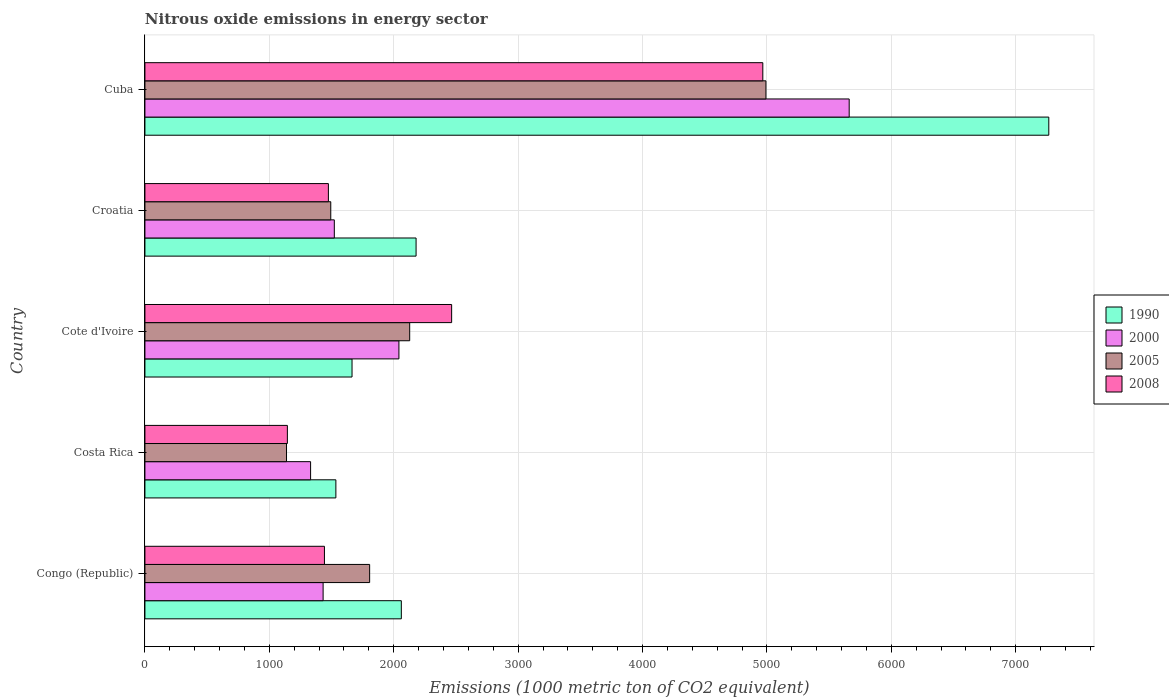How many groups of bars are there?
Your answer should be very brief. 5. Are the number of bars per tick equal to the number of legend labels?
Your answer should be very brief. Yes. Are the number of bars on each tick of the Y-axis equal?
Ensure brevity in your answer.  Yes. How many bars are there on the 2nd tick from the bottom?
Offer a very short reply. 4. What is the label of the 3rd group of bars from the top?
Your answer should be very brief. Cote d'Ivoire. In how many cases, is the number of bars for a given country not equal to the number of legend labels?
Offer a terse response. 0. What is the amount of nitrous oxide emitted in 2008 in Cuba?
Keep it short and to the point. 4967. Across all countries, what is the maximum amount of nitrous oxide emitted in 2005?
Keep it short and to the point. 4992.1. Across all countries, what is the minimum amount of nitrous oxide emitted in 2008?
Offer a terse response. 1145.2. In which country was the amount of nitrous oxide emitted in 2005 maximum?
Make the answer very short. Cuba. What is the total amount of nitrous oxide emitted in 1990 in the graph?
Offer a terse response. 1.47e+04. What is the difference between the amount of nitrous oxide emitted in 2000 in Cote d'Ivoire and that in Croatia?
Make the answer very short. 519.3. What is the difference between the amount of nitrous oxide emitted in 2000 in Croatia and the amount of nitrous oxide emitted in 2005 in Costa Rica?
Offer a terse response. 384.3. What is the average amount of nitrous oxide emitted in 2000 per country?
Provide a succinct answer. 2397.96. In how many countries, is the amount of nitrous oxide emitted in 1990 greater than 3800 1000 metric ton?
Your answer should be compact. 1. What is the ratio of the amount of nitrous oxide emitted in 2008 in Cote d'Ivoire to that in Cuba?
Give a very brief answer. 0.5. What is the difference between the highest and the second highest amount of nitrous oxide emitted in 2005?
Give a very brief answer. 2863.8. What is the difference between the highest and the lowest amount of nitrous oxide emitted in 2008?
Your answer should be very brief. 3821.8. In how many countries, is the amount of nitrous oxide emitted in 2000 greater than the average amount of nitrous oxide emitted in 2000 taken over all countries?
Your answer should be compact. 1. Is the sum of the amount of nitrous oxide emitted in 2005 in Congo (Republic) and Cuba greater than the maximum amount of nitrous oxide emitted in 2000 across all countries?
Your answer should be very brief. Yes. What does the 1st bar from the top in Costa Rica represents?
Provide a short and direct response. 2008. What is the difference between two consecutive major ticks on the X-axis?
Offer a terse response. 1000. Does the graph contain grids?
Your response must be concise. Yes. How many legend labels are there?
Your answer should be very brief. 4. How are the legend labels stacked?
Ensure brevity in your answer.  Vertical. What is the title of the graph?
Keep it short and to the point. Nitrous oxide emissions in energy sector. What is the label or title of the X-axis?
Provide a succinct answer. Emissions (1000 metric ton of CO2 equivalent). What is the label or title of the Y-axis?
Provide a short and direct response. Country. What is the Emissions (1000 metric ton of CO2 equivalent) in 1990 in Congo (Republic)?
Ensure brevity in your answer.  2061.2. What is the Emissions (1000 metric ton of CO2 equivalent) in 2000 in Congo (Republic)?
Make the answer very short. 1432.4. What is the Emissions (1000 metric ton of CO2 equivalent) of 2005 in Congo (Republic)?
Provide a short and direct response. 1806.4. What is the Emissions (1000 metric ton of CO2 equivalent) of 2008 in Congo (Republic)?
Provide a short and direct response. 1443.1. What is the Emissions (1000 metric ton of CO2 equivalent) of 1990 in Costa Rica?
Provide a succinct answer. 1535. What is the Emissions (1000 metric ton of CO2 equivalent) in 2000 in Costa Rica?
Offer a terse response. 1331.8. What is the Emissions (1000 metric ton of CO2 equivalent) in 2005 in Costa Rica?
Provide a succinct answer. 1138.2. What is the Emissions (1000 metric ton of CO2 equivalent) of 2008 in Costa Rica?
Your response must be concise. 1145.2. What is the Emissions (1000 metric ton of CO2 equivalent) of 1990 in Cote d'Ivoire?
Make the answer very short. 1664.9. What is the Emissions (1000 metric ton of CO2 equivalent) in 2000 in Cote d'Ivoire?
Keep it short and to the point. 2041.8. What is the Emissions (1000 metric ton of CO2 equivalent) in 2005 in Cote d'Ivoire?
Your answer should be compact. 2128.3. What is the Emissions (1000 metric ton of CO2 equivalent) in 2008 in Cote d'Ivoire?
Keep it short and to the point. 2465.6. What is the Emissions (1000 metric ton of CO2 equivalent) of 1990 in Croatia?
Provide a short and direct response. 2179.7. What is the Emissions (1000 metric ton of CO2 equivalent) of 2000 in Croatia?
Offer a terse response. 1522.5. What is the Emissions (1000 metric ton of CO2 equivalent) in 2005 in Croatia?
Offer a very short reply. 1494. What is the Emissions (1000 metric ton of CO2 equivalent) of 2008 in Croatia?
Keep it short and to the point. 1474.8. What is the Emissions (1000 metric ton of CO2 equivalent) in 1990 in Cuba?
Ensure brevity in your answer.  7265.9. What is the Emissions (1000 metric ton of CO2 equivalent) of 2000 in Cuba?
Your response must be concise. 5661.3. What is the Emissions (1000 metric ton of CO2 equivalent) of 2005 in Cuba?
Provide a short and direct response. 4992.1. What is the Emissions (1000 metric ton of CO2 equivalent) of 2008 in Cuba?
Give a very brief answer. 4967. Across all countries, what is the maximum Emissions (1000 metric ton of CO2 equivalent) of 1990?
Offer a terse response. 7265.9. Across all countries, what is the maximum Emissions (1000 metric ton of CO2 equivalent) of 2000?
Your answer should be compact. 5661.3. Across all countries, what is the maximum Emissions (1000 metric ton of CO2 equivalent) in 2005?
Provide a short and direct response. 4992.1. Across all countries, what is the maximum Emissions (1000 metric ton of CO2 equivalent) of 2008?
Your answer should be very brief. 4967. Across all countries, what is the minimum Emissions (1000 metric ton of CO2 equivalent) in 1990?
Your answer should be compact. 1535. Across all countries, what is the minimum Emissions (1000 metric ton of CO2 equivalent) of 2000?
Make the answer very short. 1331.8. Across all countries, what is the minimum Emissions (1000 metric ton of CO2 equivalent) in 2005?
Make the answer very short. 1138.2. Across all countries, what is the minimum Emissions (1000 metric ton of CO2 equivalent) of 2008?
Offer a terse response. 1145.2. What is the total Emissions (1000 metric ton of CO2 equivalent) in 1990 in the graph?
Keep it short and to the point. 1.47e+04. What is the total Emissions (1000 metric ton of CO2 equivalent) of 2000 in the graph?
Offer a terse response. 1.20e+04. What is the total Emissions (1000 metric ton of CO2 equivalent) in 2005 in the graph?
Offer a terse response. 1.16e+04. What is the total Emissions (1000 metric ton of CO2 equivalent) in 2008 in the graph?
Offer a very short reply. 1.15e+04. What is the difference between the Emissions (1000 metric ton of CO2 equivalent) in 1990 in Congo (Republic) and that in Costa Rica?
Provide a succinct answer. 526.2. What is the difference between the Emissions (1000 metric ton of CO2 equivalent) in 2000 in Congo (Republic) and that in Costa Rica?
Give a very brief answer. 100.6. What is the difference between the Emissions (1000 metric ton of CO2 equivalent) of 2005 in Congo (Republic) and that in Costa Rica?
Ensure brevity in your answer.  668.2. What is the difference between the Emissions (1000 metric ton of CO2 equivalent) in 2008 in Congo (Republic) and that in Costa Rica?
Offer a very short reply. 297.9. What is the difference between the Emissions (1000 metric ton of CO2 equivalent) of 1990 in Congo (Republic) and that in Cote d'Ivoire?
Ensure brevity in your answer.  396.3. What is the difference between the Emissions (1000 metric ton of CO2 equivalent) in 2000 in Congo (Republic) and that in Cote d'Ivoire?
Offer a terse response. -609.4. What is the difference between the Emissions (1000 metric ton of CO2 equivalent) of 2005 in Congo (Republic) and that in Cote d'Ivoire?
Keep it short and to the point. -321.9. What is the difference between the Emissions (1000 metric ton of CO2 equivalent) of 2008 in Congo (Republic) and that in Cote d'Ivoire?
Offer a terse response. -1022.5. What is the difference between the Emissions (1000 metric ton of CO2 equivalent) in 1990 in Congo (Republic) and that in Croatia?
Your response must be concise. -118.5. What is the difference between the Emissions (1000 metric ton of CO2 equivalent) in 2000 in Congo (Republic) and that in Croatia?
Your answer should be very brief. -90.1. What is the difference between the Emissions (1000 metric ton of CO2 equivalent) of 2005 in Congo (Republic) and that in Croatia?
Provide a succinct answer. 312.4. What is the difference between the Emissions (1000 metric ton of CO2 equivalent) in 2008 in Congo (Republic) and that in Croatia?
Ensure brevity in your answer.  -31.7. What is the difference between the Emissions (1000 metric ton of CO2 equivalent) in 1990 in Congo (Republic) and that in Cuba?
Your response must be concise. -5204.7. What is the difference between the Emissions (1000 metric ton of CO2 equivalent) of 2000 in Congo (Republic) and that in Cuba?
Offer a very short reply. -4228.9. What is the difference between the Emissions (1000 metric ton of CO2 equivalent) in 2005 in Congo (Republic) and that in Cuba?
Provide a succinct answer. -3185.7. What is the difference between the Emissions (1000 metric ton of CO2 equivalent) of 2008 in Congo (Republic) and that in Cuba?
Your answer should be compact. -3523.9. What is the difference between the Emissions (1000 metric ton of CO2 equivalent) of 1990 in Costa Rica and that in Cote d'Ivoire?
Provide a succinct answer. -129.9. What is the difference between the Emissions (1000 metric ton of CO2 equivalent) in 2000 in Costa Rica and that in Cote d'Ivoire?
Give a very brief answer. -710. What is the difference between the Emissions (1000 metric ton of CO2 equivalent) in 2005 in Costa Rica and that in Cote d'Ivoire?
Your answer should be compact. -990.1. What is the difference between the Emissions (1000 metric ton of CO2 equivalent) in 2008 in Costa Rica and that in Cote d'Ivoire?
Ensure brevity in your answer.  -1320.4. What is the difference between the Emissions (1000 metric ton of CO2 equivalent) in 1990 in Costa Rica and that in Croatia?
Provide a succinct answer. -644.7. What is the difference between the Emissions (1000 metric ton of CO2 equivalent) of 2000 in Costa Rica and that in Croatia?
Keep it short and to the point. -190.7. What is the difference between the Emissions (1000 metric ton of CO2 equivalent) of 2005 in Costa Rica and that in Croatia?
Give a very brief answer. -355.8. What is the difference between the Emissions (1000 metric ton of CO2 equivalent) of 2008 in Costa Rica and that in Croatia?
Ensure brevity in your answer.  -329.6. What is the difference between the Emissions (1000 metric ton of CO2 equivalent) of 1990 in Costa Rica and that in Cuba?
Your answer should be compact. -5730.9. What is the difference between the Emissions (1000 metric ton of CO2 equivalent) in 2000 in Costa Rica and that in Cuba?
Offer a terse response. -4329.5. What is the difference between the Emissions (1000 metric ton of CO2 equivalent) in 2005 in Costa Rica and that in Cuba?
Offer a very short reply. -3853.9. What is the difference between the Emissions (1000 metric ton of CO2 equivalent) in 2008 in Costa Rica and that in Cuba?
Keep it short and to the point. -3821.8. What is the difference between the Emissions (1000 metric ton of CO2 equivalent) in 1990 in Cote d'Ivoire and that in Croatia?
Make the answer very short. -514.8. What is the difference between the Emissions (1000 metric ton of CO2 equivalent) of 2000 in Cote d'Ivoire and that in Croatia?
Offer a very short reply. 519.3. What is the difference between the Emissions (1000 metric ton of CO2 equivalent) in 2005 in Cote d'Ivoire and that in Croatia?
Make the answer very short. 634.3. What is the difference between the Emissions (1000 metric ton of CO2 equivalent) of 2008 in Cote d'Ivoire and that in Croatia?
Provide a succinct answer. 990.8. What is the difference between the Emissions (1000 metric ton of CO2 equivalent) in 1990 in Cote d'Ivoire and that in Cuba?
Provide a short and direct response. -5601. What is the difference between the Emissions (1000 metric ton of CO2 equivalent) of 2000 in Cote d'Ivoire and that in Cuba?
Offer a terse response. -3619.5. What is the difference between the Emissions (1000 metric ton of CO2 equivalent) of 2005 in Cote d'Ivoire and that in Cuba?
Ensure brevity in your answer.  -2863.8. What is the difference between the Emissions (1000 metric ton of CO2 equivalent) in 2008 in Cote d'Ivoire and that in Cuba?
Give a very brief answer. -2501.4. What is the difference between the Emissions (1000 metric ton of CO2 equivalent) of 1990 in Croatia and that in Cuba?
Provide a succinct answer. -5086.2. What is the difference between the Emissions (1000 metric ton of CO2 equivalent) in 2000 in Croatia and that in Cuba?
Keep it short and to the point. -4138.8. What is the difference between the Emissions (1000 metric ton of CO2 equivalent) of 2005 in Croatia and that in Cuba?
Your answer should be very brief. -3498.1. What is the difference between the Emissions (1000 metric ton of CO2 equivalent) in 2008 in Croatia and that in Cuba?
Your response must be concise. -3492.2. What is the difference between the Emissions (1000 metric ton of CO2 equivalent) in 1990 in Congo (Republic) and the Emissions (1000 metric ton of CO2 equivalent) in 2000 in Costa Rica?
Offer a terse response. 729.4. What is the difference between the Emissions (1000 metric ton of CO2 equivalent) of 1990 in Congo (Republic) and the Emissions (1000 metric ton of CO2 equivalent) of 2005 in Costa Rica?
Your answer should be very brief. 923. What is the difference between the Emissions (1000 metric ton of CO2 equivalent) of 1990 in Congo (Republic) and the Emissions (1000 metric ton of CO2 equivalent) of 2008 in Costa Rica?
Offer a very short reply. 916. What is the difference between the Emissions (1000 metric ton of CO2 equivalent) in 2000 in Congo (Republic) and the Emissions (1000 metric ton of CO2 equivalent) in 2005 in Costa Rica?
Offer a terse response. 294.2. What is the difference between the Emissions (1000 metric ton of CO2 equivalent) of 2000 in Congo (Republic) and the Emissions (1000 metric ton of CO2 equivalent) of 2008 in Costa Rica?
Provide a short and direct response. 287.2. What is the difference between the Emissions (1000 metric ton of CO2 equivalent) of 2005 in Congo (Republic) and the Emissions (1000 metric ton of CO2 equivalent) of 2008 in Costa Rica?
Make the answer very short. 661.2. What is the difference between the Emissions (1000 metric ton of CO2 equivalent) in 1990 in Congo (Republic) and the Emissions (1000 metric ton of CO2 equivalent) in 2005 in Cote d'Ivoire?
Make the answer very short. -67.1. What is the difference between the Emissions (1000 metric ton of CO2 equivalent) in 1990 in Congo (Republic) and the Emissions (1000 metric ton of CO2 equivalent) in 2008 in Cote d'Ivoire?
Make the answer very short. -404.4. What is the difference between the Emissions (1000 metric ton of CO2 equivalent) of 2000 in Congo (Republic) and the Emissions (1000 metric ton of CO2 equivalent) of 2005 in Cote d'Ivoire?
Your answer should be compact. -695.9. What is the difference between the Emissions (1000 metric ton of CO2 equivalent) of 2000 in Congo (Republic) and the Emissions (1000 metric ton of CO2 equivalent) of 2008 in Cote d'Ivoire?
Keep it short and to the point. -1033.2. What is the difference between the Emissions (1000 metric ton of CO2 equivalent) in 2005 in Congo (Republic) and the Emissions (1000 metric ton of CO2 equivalent) in 2008 in Cote d'Ivoire?
Provide a succinct answer. -659.2. What is the difference between the Emissions (1000 metric ton of CO2 equivalent) of 1990 in Congo (Republic) and the Emissions (1000 metric ton of CO2 equivalent) of 2000 in Croatia?
Ensure brevity in your answer.  538.7. What is the difference between the Emissions (1000 metric ton of CO2 equivalent) of 1990 in Congo (Republic) and the Emissions (1000 metric ton of CO2 equivalent) of 2005 in Croatia?
Provide a short and direct response. 567.2. What is the difference between the Emissions (1000 metric ton of CO2 equivalent) of 1990 in Congo (Republic) and the Emissions (1000 metric ton of CO2 equivalent) of 2008 in Croatia?
Offer a terse response. 586.4. What is the difference between the Emissions (1000 metric ton of CO2 equivalent) in 2000 in Congo (Republic) and the Emissions (1000 metric ton of CO2 equivalent) in 2005 in Croatia?
Give a very brief answer. -61.6. What is the difference between the Emissions (1000 metric ton of CO2 equivalent) in 2000 in Congo (Republic) and the Emissions (1000 metric ton of CO2 equivalent) in 2008 in Croatia?
Ensure brevity in your answer.  -42.4. What is the difference between the Emissions (1000 metric ton of CO2 equivalent) of 2005 in Congo (Republic) and the Emissions (1000 metric ton of CO2 equivalent) of 2008 in Croatia?
Your answer should be compact. 331.6. What is the difference between the Emissions (1000 metric ton of CO2 equivalent) in 1990 in Congo (Republic) and the Emissions (1000 metric ton of CO2 equivalent) in 2000 in Cuba?
Ensure brevity in your answer.  -3600.1. What is the difference between the Emissions (1000 metric ton of CO2 equivalent) of 1990 in Congo (Republic) and the Emissions (1000 metric ton of CO2 equivalent) of 2005 in Cuba?
Give a very brief answer. -2930.9. What is the difference between the Emissions (1000 metric ton of CO2 equivalent) of 1990 in Congo (Republic) and the Emissions (1000 metric ton of CO2 equivalent) of 2008 in Cuba?
Your answer should be very brief. -2905.8. What is the difference between the Emissions (1000 metric ton of CO2 equivalent) in 2000 in Congo (Republic) and the Emissions (1000 metric ton of CO2 equivalent) in 2005 in Cuba?
Offer a terse response. -3559.7. What is the difference between the Emissions (1000 metric ton of CO2 equivalent) of 2000 in Congo (Republic) and the Emissions (1000 metric ton of CO2 equivalent) of 2008 in Cuba?
Your response must be concise. -3534.6. What is the difference between the Emissions (1000 metric ton of CO2 equivalent) of 2005 in Congo (Republic) and the Emissions (1000 metric ton of CO2 equivalent) of 2008 in Cuba?
Give a very brief answer. -3160.6. What is the difference between the Emissions (1000 metric ton of CO2 equivalent) in 1990 in Costa Rica and the Emissions (1000 metric ton of CO2 equivalent) in 2000 in Cote d'Ivoire?
Provide a short and direct response. -506.8. What is the difference between the Emissions (1000 metric ton of CO2 equivalent) of 1990 in Costa Rica and the Emissions (1000 metric ton of CO2 equivalent) of 2005 in Cote d'Ivoire?
Offer a very short reply. -593.3. What is the difference between the Emissions (1000 metric ton of CO2 equivalent) in 1990 in Costa Rica and the Emissions (1000 metric ton of CO2 equivalent) in 2008 in Cote d'Ivoire?
Ensure brevity in your answer.  -930.6. What is the difference between the Emissions (1000 metric ton of CO2 equivalent) of 2000 in Costa Rica and the Emissions (1000 metric ton of CO2 equivalent) of 2005 in Cote d'Ivoire?
Your response must be concise. -796.5. What is the difference between the Emissions (1000 metric ton of CO2 equivalent) in 2000 in Costa Rica and the Emissions (1000 metric ton of CO2 equivalent) in 2008 in Cote d'Ivoire?
Your answer should be compact. -1133.8. What is the difference between the Emissions (1000 metric ton of CO2 equivalent) of 2005 in Costa Rica and the Emissions (1000 metric ton of CO2 equivalent) of 2008 in Cote d'Ivoire?
Offer a very short reply. -1327.4. What is the difference between the Emissions (1000 metric ton of CO2 equivalent) of 1990 in Costa Rica and the Emissions (1000 metric ton of CO2 equivalent) of 2000 in Croatia?
Your response must be concise. 12.5. What is the difference between the Emissions (1000 metric ton of CO2 equivalent) of 1990 in Costa Rica and the Emissions (1000 metric ton of CO2 equivalent) of 2005 in Croatia?
Make the answer very short. 41. What is the difference between the Emissions (1000 metric ton of CO2 equivalent) in 1990 in Costa Rica and the Emissions (1000 metric ton of CO2 equivalent) in 2008 in Croatia?
Offer a terse response. 60.2. What is the difference between the Emissions (1000 metric ton of CO2 equivalent) of 2000 in Costa Rica and the Emissions (1000 metric ton of CO2 equivalent) of 2005 in Croatia?
Provide a short and direct response. -162.2. What is the difference between the Emissions (1000 metric ton of CO2 equivalent) in 2000 in Costa Rica and the Emissions (1000 metric ton of CO2 equivalent) in 2008 in Croatia?
Your answer should be compact. -143. What is the difference between the Emissions (1000 metric ton of CO2 equivalent) in 2005 in Costa Rica and the Emissions (1000 metric ton of CO2 equivalent) in 2008 in Croatia?
Provide a short and direct response. -336.6. What is the difference between the Emissions (1000 metric ton of CO2 equivalent) of 1990 in Costa Rica and the Emissions (1000 metric ton of CO2 equivalent) of 2000 in Cuba?
Provide a short and direct response. -4126.3. What is the difference between the Emissions (1000 metric ton of CO2 equivalent) of 1990 in Costa Rica and the Emissions (1000 metric ton of CO2 equivalent) of 2005 in Cuba?
Your answer should be compact. -3457.1. What is the difference between the Emissions (1000 metric ton of CO2 equivalent) in 1990 in Costa Rica and the Emissions (1000 metric ton of CO2 equivalent) in 2008 in Cuba?
Make the answer very short. -3432. What is the difference between the Emissions (1000 metric ton of CO2 equivalent) of 2000 in Costa Rica and the Emissions (1000 metric ton of CO2 equivalent) of 2005 in Cuba?
Your response must be concise. -3660.3. What is the difference between the Emissions (1000 metric ton of CO2 equivalent) in 2000 in Costa Rica and the Emissions (1000 metric ton of CO2 equivalent) in 2008 in Cuba?
Ensure brevity in your answer.  -3635.2. What is the difference between the Emissions (1000 metric ton of CO2 equivalent) in 2005 in Costa Rica and the Emissions (1000 metric ton of CO2 equivalent) in 2008 in Cuba?
Provide a short and direct response. -3828.8. What is the difference between the Emissions (1000 metric ton of CO2 equivalent) in 1990 in Cote d'Ivoire and the Emissions (1000 metric ton of CO2 equivalent) in 2000 in Croatia?
Ensure brevity in your answer.  142.4. What is the difference between the Emissions (1000 metric ton of CO2 equivalent) in 1990 in Cote d'Ivoire and the Emissions (1000 metric ton of CO2 equivalent) in 2005 in Croatia?
Offer a terse response. 170.9. What is the difference between the Emissions (1000 metric ton of CO2 equivalent) in 1990 in Cote d'Ivoire and the Emissions (1000 metric ton of CO2 equivalent) in 2008 in Croatia?
Give a very brief answer. 190.1. What is the difference between the Emissions (1000 metric ton of CO2 equivalent) of 2000 in Cote d'Ivoire and the Emissions (1000 metric ton of CO2 equivalent) of 2005 in Croatia?
Give a very brief answer. 547.8. What is the difference between the Emissions (1000 metric ton of CO2 equivalent) of 2000 in Cote d'Ivoire and the Emissions (1000 metric ton of CO2 equivalent) of 2008 in Croatia?
Your answer should be compact. 567. What is the difference between the Emissions (1000 metric ton of CO2 equivalent) in 2005 in Cote d'Ivoire and the Emissions (1000 metric ton of CO2 equivalent) in 2008 in Croatia?
Ensure brevity in your answer.  653.5. What is the difference between the Emissions (1000 metric ton of CO2 equivalent) of 1990 in Cote d'Ivoire and the Emissions (1000 metric ton of CO2 equivalent) of 2000 in Cuba?
Your answer should be compact. -3996.4. What is the difference between the Emissions (1000 metric ton of CO2 equivalent) in 1990 in Cote d'Ivoire and the Emissions (1000 metric ton of CO2 equivalent) in 2005 in Cuba?
Keep it short and to the point. -3327.2. What is the difference between the Emissions (1000 metric ton of CO2 equivalent) of 1990 in Cote d'Ivoire and the Emissions (1000 metric ton of CO2 equivalent) of 2008 in Cuba?
Ensure brevity in your answer.  -3302.1. What is the difference between the Emissions (1000 metric ton of CO2 equivalent) in 2000 in Cote d'Ivoire and the Emissions (1000 metric ton of CO2 equivalent) in 2005 in Cuba?
Offer a very short reply. -2950.3. What is the difference between the Emissions (1000 metric ton of CO2 equivalent) in 2000 in Cote d'Ivoire and the Emissions (1000 metric ton of CO2 equivalent) in 2008 in Cuba?
Offer a terse response. -2925.2. What is the difference between the Emissions (1000 metric ton of CO2 equivalent) in 2005 in Cote d'Ivoire and the Emissions (1000 metric ton of CO2 equivalent) in 2008 in Cuba?
Ensure brevity in your answer.  -2838.7. What is the difference between the Emissions (1000 metric ton of CO2 equivalent) in 1990 in Croatia and the Emissions (1000 metric ton of CO2 equivalent) in 2000 in Cuba?
Your response must be concise. -3481.6. What is the difference between the Emissions (1000 metric ton of CO2 equivalent) in 1990 in Croatia and the Emissions (1000 metric ton of CO2 equivalent) in 2005 in Cuba?
Your answer should be very brief. -2812.4. What is the difference between the Emissions (1000 metric ton of CO2 equivalent) in 1990 in Croatia and the Emissions (1000 metric ton of CO2 equivalent) in 2008 in Cuba?
Offer a terse response. -2787.3. What is the difference between the Emissions (1000 metric ton of CO2 equivalent) in 2000 in Croatia and the Emissions (1000 metric ton of CO2 equivalent) in 2005 in Cuba?
Give a very brief answer. -3469.6. What is the difference between the Emissions (1000 metric ton of CO2 equivalent) in 2000 in Croatia and the Emissions (1000 metric ton of CO2 equivalent) in 2008 in Cuba?
Provide a short and direct response. -3444.5. What is the difference between the Emissions (1000 metric ton of CO2 equivalent) in 2005 in Croatia and the Emissions (1000 metric ton of CO2 equivalent) in 2008 in Cuba?
Keep it short and to the point. -3473. What is the average Emissions (1000 metric ton of CO2 equivalent) in 1990 per country?
Keep it short and to the point. 2941.34. What is the average Emissions (1000 metric ton of CO2 equivalent) in 2000 per country?
Your response must be concise. 2397.96. What is the average Emissions (1000 metric ton of CO2 equivalent) of 2005 per country?
Make the answer very short. 2311.8. What is the average Emissions (1000 metric ton of CO2 equivalent) of 2008 per country?
Your response must be concise. 2299.14. What is the difference between the Emissions (1000 metric ton of CO2 equivalent) of 1990 and Emissions (1000 metric ton of CO2 equivalent) of 2000 in Congo (Republic)?
Ensure brevity in your answer.  628.8. What is the difference between the Emissions (1000 metric ton of CO2 equivalent) in 1990 and Emissions (1000 metric ton of CO2 equivalent) in 2005 in Congo (Republic)?
Provide a succinct answer. 254.8. What is the difference between the Emissions (1000 metric ton of CO2 equivalent) in 1990 and Emissions (1000 metric ton of CO2 equivalent) in 2008 in Congo (Republic)?
Your response must be concise. 618.1. What is the difference between the Emissions (1000 metric ton of CO2 equivalent) in 2000 and Emissions (1000 metric ton of CO2 equivalent) in 2005 in Congo (Republic)?
Your answer should be compact. -374. What is the difference between the Emissions (1000 metric ton of CO2 equivalent) in 2000 and Emissions (1000 metric ton of CO2 equivalent) in 2008 in Congo (Republic)?
Provide a succinct answer. -10.7. What is the difference between the Emissions (1000 metric ton of CO2 equivalent) of 2005 and Emissions (1000 metric ton of CO2 equivalent) of 2008 in Congo (Republic)?
Provide a succinct answer. 363.3. What is the difference between the Emissions (1000 metric ton of CO2 equivalent) of 1990 and Emissions (1000 metric ton of CO2 equivalent) of 2000 in Costa Rica?
Your answer should be compact. 203.2. What is the difference between the Emissions (1000 metric ton of CO2 equivalent) in 1990 and Emissions (1000 metric ton of CO2 equivalent) in 2005 in Costa Rica?
Offer a very short reply. 396.8. What is the difference between the Emissions (1000 metric ton of CO2 equivalent) in 1990 and Emissions (1000 metric ton of CO2 equivalent) in 2008 in Costa Rica?
Provide a succinct answer. 389.8. What is the difference between the Emissions (1000 metric ton of CO2 equivalent) of 2000 and Emissions (1000 metric ton of CO2 equivalent) of 2005 in Costa Rica?
Your response must be concise. 193.6. What is the difference between the Emissions (1000 metric ton of CO2 equivalent) in 2000 and Emissions (1000 metric ton of CO2 equivalent) in 2008 in Costa Rica?
Your answer should be compact. 186.6. What is the difference between the Emissions (1000 metric ton of CO2 equivalent) in 2005 and Emissions (1000 metric ton of CO2 equivalent) in 2008 in Costa Rica?
Give a very brief answer. -7. What is the difference between the Emissions (1000 metric ton of CO2 equivalent) of 1990 and Emissions (1000 metric ton of CO2 equivalent) of 2000 in Cote d'Ivoire?
Provide a short and direct response. -376.9. What is the difference between the Emissions (1000 metric ton of CO2 equivalent) of 1990 and Emissions (1000 metric ton of CO2 equivalent) of 2005 in Cote d'Ivoire?
Make the answer very short. -463.4. What is the difference between the Emissions (1000 metric ton of CO2 equivalent) of 1990 and Emissions (1000 metric ton of CO2 equivalent) of 2008 in Cote d'Ivoire?
Make the answer very short. -800.7. What is the difference between the Emissions (1000 metric ton of CO2 equivalent) of 2000 and Emissions (1000 metric ton of CO2 equivalent) of 2005 in Cote d'Ivoire?
Offer a very short reply. -86.5. What is the difference between the Emissions (1000 metric ton of CO2 equivalent) in 2000 and Emissions (1000 metric ton of CO2 equivalent) in 2008 in Cote d'Ivoire?
Make the answer very short. -423.8. What is the difference between the Emissions (1000 metric ton of CO2 equivalent) in 2005 and Emissions (1000 metric ton of CO2 equivalent) in 2008 in Cote d'Ivoire?
Provide a short and direct response. -337.3. What is the difference between the Emissions (1000 metric ton of CO2 equivalent) in 1990 and Emissions (1000 metric ton of CO2 equivalent) in 2000 in Croatia?
Offer a very short reply. 657.2. What is the difference between the Emissions (1000 metric ton of CO2 equivalent) in 1990 and Emissions (1000 metric ton of CO2 equivalent) in 2005 in Croatia?
Your response must be concise. 685.7. What is the difference between the Emissions (1000 metric ton of CO2 equivalent) in 1990 and Emissions (1000 metric ton of CO2 equivalent) in 2008 in Croatia?
Your answer should be compact. 704.9. What is the difference between the Emissions (1000 metric ton of CO2 equivalent) of 2000 and Emissions (1000 metric ton of CO2 equivalent) of 2005 in Croatia?
Give a very brief answer. 28.5. What is the difference between the Emissions (1000 metric ton of CO2 equivalent) in 2000 and Emissions (1000 metric ton of CO2 equivalent) in 2008 in Croatia?
Your answer should be compact. 47.7. What is the difference between the Emissions (1000 metric ton of CO2 equivalent) of 1990 and Emissions (1000 metric ton of CO2 equivalent) of 2000 in Cuba?
Provide a succinct answer. 1604.6. What is the difference between the Emissions (1000 metric ton of CO2 equivalent) in 1990 and Emissions (1000 metric ton of CO2 equivalent) in 2005 in Cuba?
Your answer should be compact. 2273.8. What is the difference between the Emissions (1000 metric ton of CO2 equivalent) of 1990 and Emissions (1000 metric ton of CO2 equivalent) of 2008 in Cuba?
Make the answer very short. 2298.9. What is the difference between the Emissions (1000 metric ton of CO2 equivalent) of 2000 and Emissions (1000 metric ton of CO2 equivalent) of 2005 in Cuba?
Make the answer very short. 669.2. What is the difference between the Emissions (1000 metric ton of CO2 equivalent) of 2000 and Emissions (1000 metric ton of CO2 equivalent) of 2008 in Cuba?
Make the answer very short. 694.3. What is the difference between the Emissions (1000 metric ton of CO2 equivalent) of 2005 and Emissions (1000 metric ton of CO2 equivalent) of 2008 in Cuba?
Provide a short and direct response. 25.1. What is the ratio of the Emissions (1000 metric ton of CO2 equivalent) of 1990 in Congo (Republic) to that in Costa Rica?
Give a very brief answer. 1.34. What is the ratio of the Emissions (1000 metric ton of CO2 equivalent) in 2000 in Congo (Republic) to that in Costa Rica?
Your answer should be compact. 1.08. What is the ratio of the Emissions (1000 metric ton of CO2 equivalent) in 2005 in Congo (Republic) to that in Costa Rica?
Keep it short and to the point. 1.59. What is the ratio of the Emissions (1000 metric ton of CO2 equivalent) of 2008 in Congo (Republic) to that in Costa Rica?
Give a very brief answer. 1.26. What is the ratio of the Emissions (1000 metric ton of CO2 equivalent) in 1990 in Congo (Republic) to that in Cote d'Ivoire?
Provide a succinct answer. 1.24. What is the ratio of the Emissions (1000 metric ton of CO2 equivalent) in 2000 in Congo (Republic) to that in Cote d'Ivoire?
Your answer should be compact. 0.7. What is the ratio of the Emissions (1000 metric ton of CO2 equivalent) in 2005 in Congo (Republic) to that in Cote d'Ivoire?
Provide a succinct answer. 0.85. What is the ratio of the Emissions (1000 metric ton of CO2 equivalent) of 2008 in Congo (Republic) to that in Cote d'Ivoire?
Make the answer very short. 0.59. What is the ratio of the Emissions (1000 metric ton of CO2 equivalent) in 1990 in Congo (Republic) to that in Croatia?
Provide a short and direct response. 0.95. What is the ratio of the Emissions (1000 metric ton of CO2 equivalent) of 2000 in Congo (Republic) to that in Croatia?
Offer a very short reply. 0.94. What is the ratio of the Emissions (1000 metric ton of CO2 equivalent) of 2005 in Congo (Republic) to that in Croatia?
Keep it short and to the point. 1.21. What is the ratio of the Emissions (1000 metric ton of CO2 equivalent) of 2008 in Congo (Republic) to that in Croatia?
Provide a succinct answer. 0.98. What is the ratio of the Emissions (1000 metric ton of CO2 equivalent) of 1990 in Congo (Republic) to that in Cuba?
Your answer should be very brief. 0.28. What is the ratio of the Emissions (1000 metric ton of CO2 equivalent) of 2000 in Congo (Republic) to that in Cuba?
Keep it short and to the point. 0.25. What is the ratio of the Emissions (1000 metric ton of CO2 equivalent) of 2005 in Congo (Republic) to that in Cuba?
Your answer should be very brief. 0.36. What is the ratio of the Emissions (1000 metric ton of CO2 equivalent) of 2008 in Congo (Republic) to that in Cuba?
Your answer should be compact. 0.29. What is the ratio of the Emissions (1000 metric ton of CO2 equivalent) of 1990 in Costa Rica to that in Cote d'Ivoire?
Make the answer very short. 0.92. What is the ratio of the Emissions (1000 metric ton of CO2 equivalent) in 2000 in Costa Rica to that in Cote d'Ivoire?
Your answer should be very brief. 0.65. What is the ratio of the Emissions (1000 metric ton of CO2 equivalent) in 2005 in Costa Rica to that in Cote d'Ivoire?
Your response must be concise. 0.53. What is the ratio of the Emissions (1000 metric ton of CO2 equivalent) in 2008 in Costa Rica to that in Cote d'Ivoire?
Your response must be concise. 0.46. What is the ratio of the Emissions (1000 metric ton of CO2 equivalent) of 1990 in Costa Rica to that in Croatia?
Your answer should be very brief. 0.7. What is the ratio of the Emissions (1000 metric ton of CO2 equivalent) in 2000 in Costa Rica to that in Croatia?
Offer a very short reply. 0.87. What is the ratio of the Emissions (1000 metric ton of CO2 equivalent) in 2005 in Costa Rica to that in Croatia?
Offer a very short reply. 0.76. What is the ratio of the Emissions (1000 metric ton of CO2 equivalent) of 2008 in Costa Rica to that in Croatia?
Keep it short and to the point. 0.78. What is the ratio of the Emissions (1000 metric ton of CO2 equivalent) of 1990 in Costa Rica to that in Cuba?
Your answer should be compact. 0.21. What is the ratio of the Emissions (1000 metric ton of CO2 equivalent) of 2000 in Costa Rica to that in Cuba?
Keep it short and to the point. 0.24. What is the ratio of the Emissions (1000 metric ton of CO2 equivalent) of 2005 in Costa Rica to that in Cuba?
Keep it short and to the point. 0.23. What is the ratio of the Emissions (1000 metric ton of CO2 equivalent) of 2008 in Costa Rica to that in Cuba?
Provide a succinct answer. 0.23. What is the ratio of the Emissions (1000 metric ton of CO2 equivalent) in 1990 in Cote d'Ivoire to that in Croatia?
Provide a succinct answer. 0.76. What is the ratio of the Emissions (1000 metric ton of CO2 equivalent) of 2000 in Cote d'Ivoire to that in Croatia?
Make the answer very short. 1.34. What is the ratio of the Emissions (1000 metric ton of CO2 equivalent) in 2005 in Cote d'Ivoire to that in Croatia?
Keep it short and to the point. 1.42. What is the ratio of the Emissions (1000 metric ton of CO2 equivalent) of 2008 in Cote d'Ivoire to that in Croatia?
Offer a very short reply. 1.67. What is the ratio of the Emissions (1000 metric ton of CO2 equivalent) in 1990 in Cote d'Ivoire to that in Cuba?
Your answer should be compact. 0.23. What is the ratio of the Emissions (1000 metric ton of CO2 equivalent) of 2000 in Cote d'Ivoire to that in Cuba?
Offer a very short reply. 0.36. What is the ratio of the Emissions (1000 metric ton of CO2 equivalent) of 2005 in Cote d'Ivoire to that in Cuba?
Your response must be concise. 0.43. What is the ratio of the Emissions (1000 metric ton of CO2 equivalent) in 2008 in Cote d'Ivoire to that in Cuba?
Give a very brief answer. 0.5. What is the ratio of the Emissions (1000 metric ton of CO2 equivalent) of 1990 in Croatia to that in Cuba?
Give a very brief answer. 0.3. What is the ratio of the Emissions (1000 metric ton of CO2 equivalent) in 2000 in Croatia to that in Cuba?
Offer a very short reply. 0.27. What is the ratio of the Emissions (1000 metric ton of CO2 equivalent) in 2005 in Croatia to that in Cuba?
Provide a succinct answer. 0.3. What is the ratio of the Emissions (1000 metric ton of CO2 equivalent) in 2008 in Croatia to that in Cuba?
Give a very brief answer. 0.3. What is the difference between the highest and the second highest Emissions (1000 metric ton of CO2 equivalent) in 1990?
Keep it short and to the point. 5086.2. What is the difference between the highest and the second highest Emissions (1000 metric ton of CO2 equivalent) of 2000?
Offer a terse response. 3619.5. What is the difference between the highest and the second highest Emissions (1000 metric ton of CO2 equivalent) in 2005?
Offer a very short reply. 2863.8. What is the difference between the highest and the second highest Emissions (1000 metric ton of CO2 equivalent) of 2008?
Make the answer very short. 2501.4. What is the difference between the highest and the lowest Emissions (1000 metric ton of CO2 equivalent) in 1990?
Offer a terse response. 5730.9. What is the difference between the highest and the lowest Emissions (1000 metric ton of CO2 equivalent) in 2000?
Your answer should be very brief. 4329.5. What is the difference between the highest and the lowest Emissions (1000 metric ton of CO2 equivalent) in 2005?
Offer a very short reply. 3853.9. What is the difference between the highest and the lowest Emissions (1000 metric ton of CO2 equivalent) of 2008?
Your response must be concise. 3821.8. 